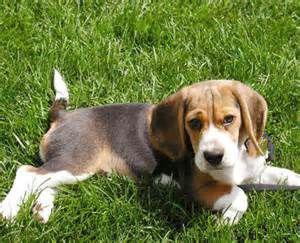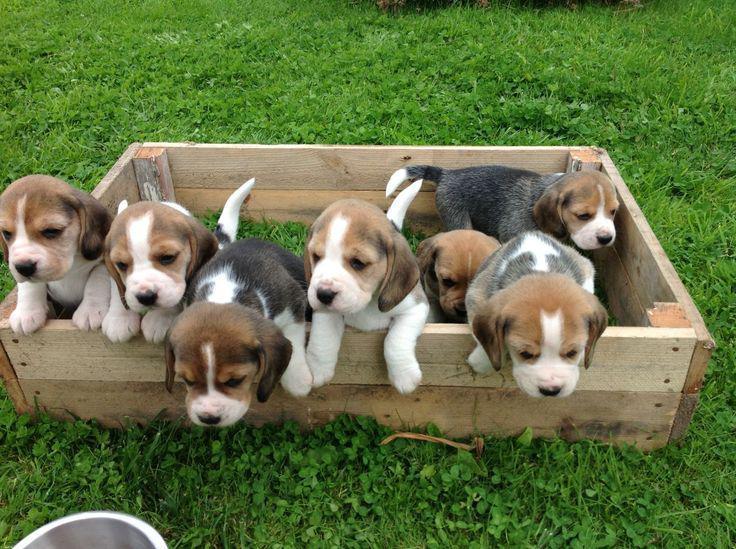The first image is the image on the left, the second image is the image on the right. For the images shown, is this caption "There are more than seven dogs." true? Answer yes or no. Yes. The first image is the image on the left, the second image is the image on the right. Given the left and right images, does the statement "Multiple beagle dogs are posed with a rectangular wooden structure, in one image." hold true? Answer yes or no. Yes. 